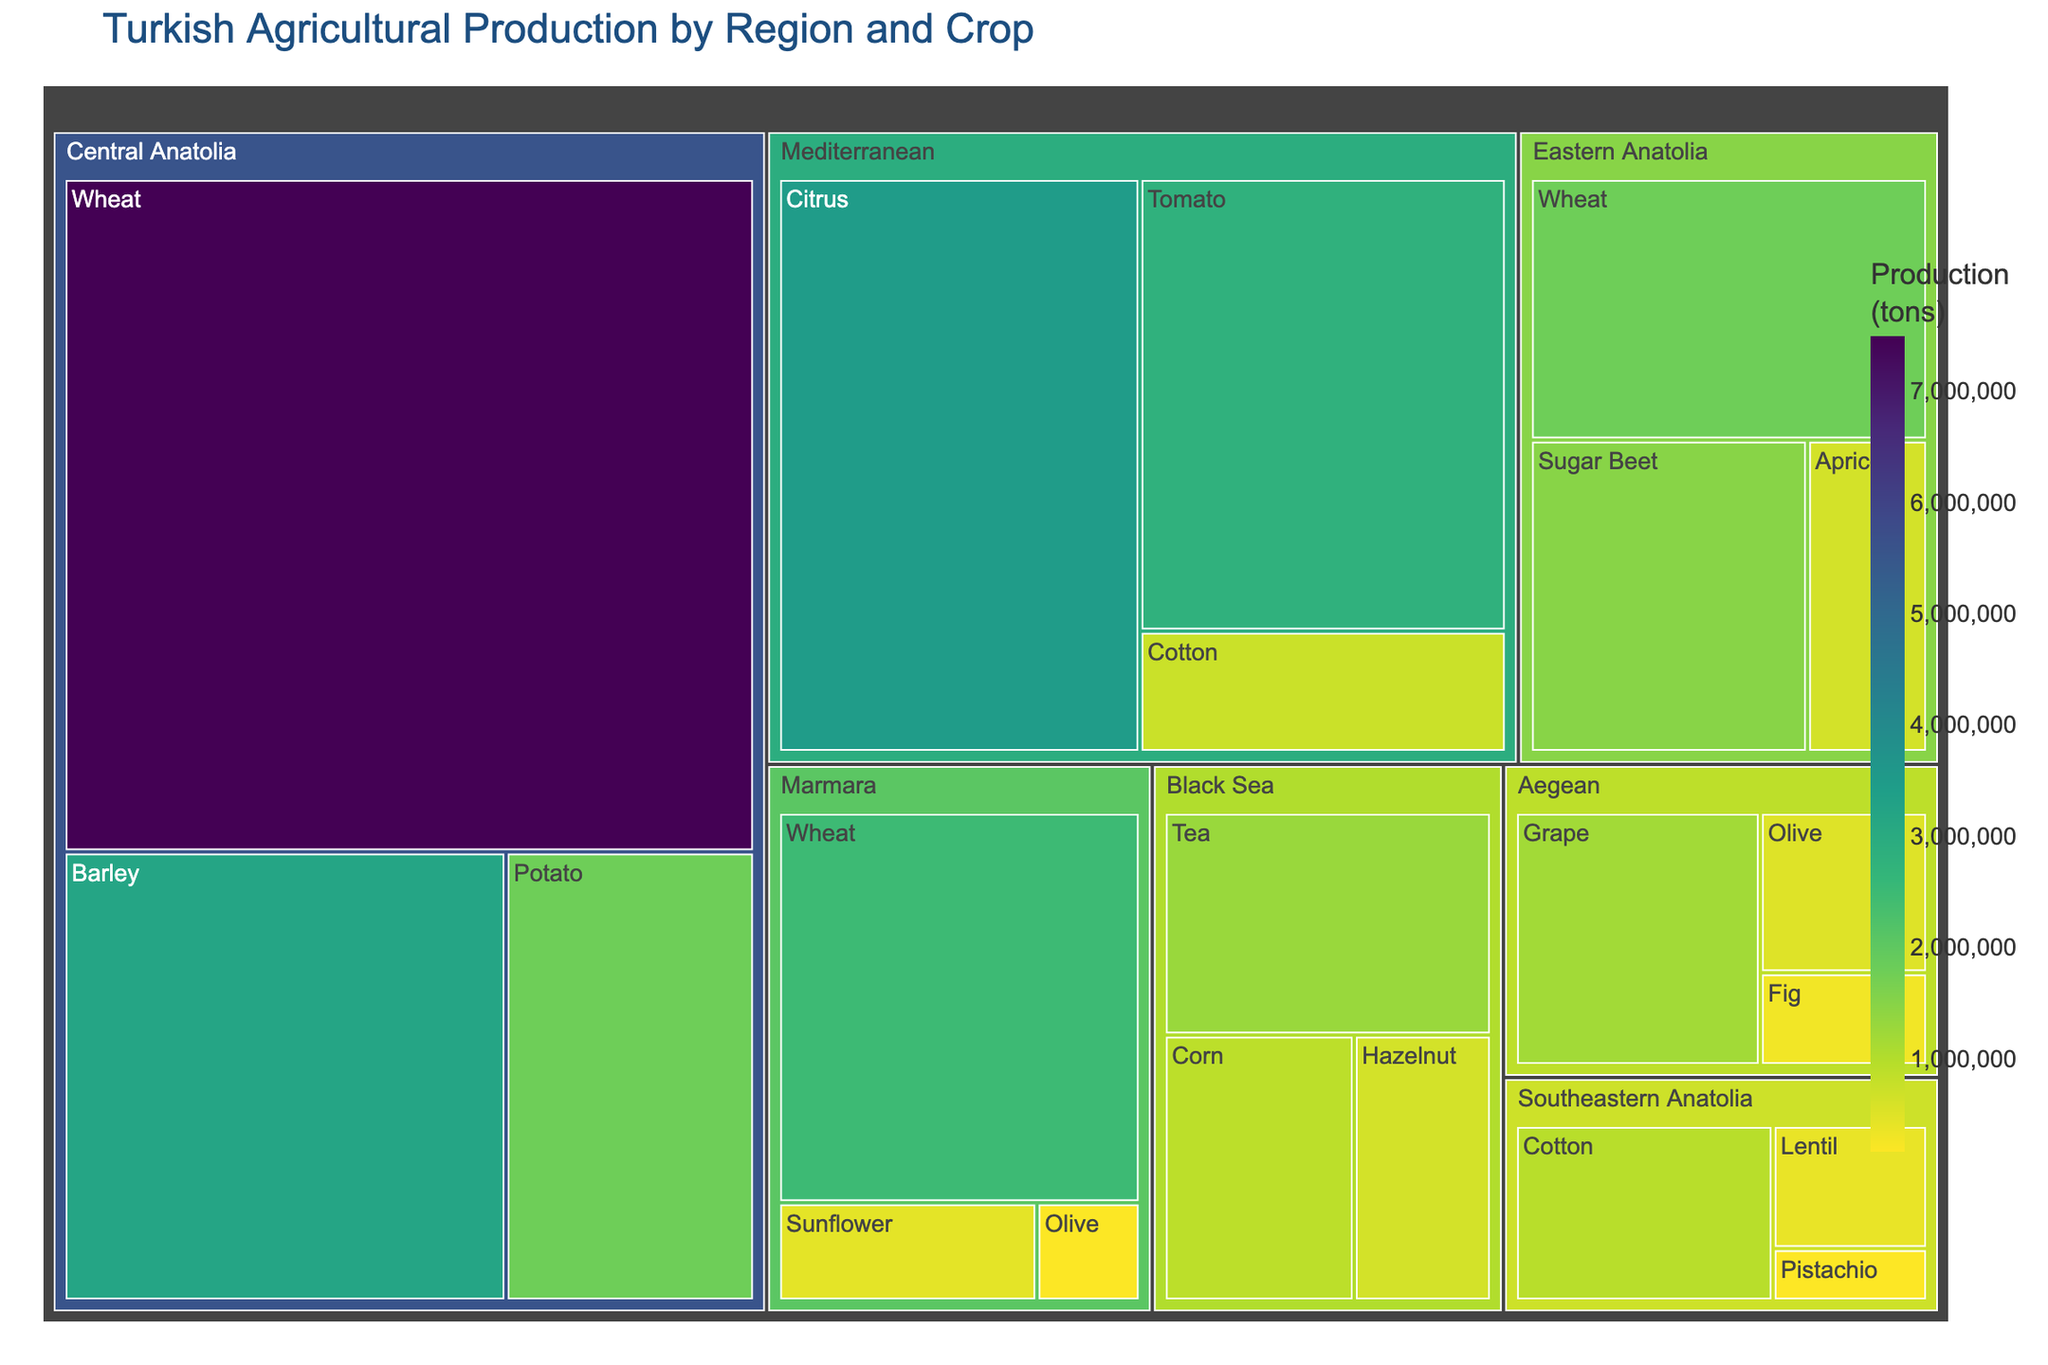Which region has the highest production of Wheat? Look for the region with the largest "Wheat" section in the treemap. Central Anatolia has the highest production of Wheat.
Answer: Central Anatolia What's the total production of Olives across all regions? Identify all the regions that produce Olives and sum their production values: Marmara (180,000) + Aegean (520,000) = 700,000 tons.
Answer: 700,000 tons Which crop in the Mediterranean region has the highest production? Within the "Mediterranean" part of the treemap, look for the largest section. Citrus has the highest production in the Mediterranean region.
Answer: Citrus How does the production of Hazelnut in the Black Sea region compare to the production of Apricot in the Eastern Anatolia region? Compare the sizes and production values of "Hazelnut" in "Black Sea" and "Apricot" in "Eastern Anatolia." Hazelnut has a production of 650,000 tons, which is equal to the Apricot production of 650,000 tons in Eastern Anatolia.
Answer: Equal What's the combined production of Tea and Corn in the Black Sea region? Find the production values of "Tea" (1,300,000) and "Corn" (900,000) in the "Black Sea" region and sum them up: 1,300,000 + 900,000 = 2,200,000 tons.
Answer: 2,200,000 tons Which region contributes the most to Cotton production in the dataset? Compare the Cotton production values across different regions depicted in the treemap. Southeastern Anatolia's Cotton production (950,000 tons) is the highest.
Answer: Southeastern Anatolia What’s the ratio of Citrus production to Tomato production in the Mediterranean region? Divide the production of Citrus (3,500,000 tons) by the production of Tomato (2,800,000 tons) in the Mediterranean: 3,500,000 / 2,800,000 ≈ 1.25.
Answer: 1.25 How many different crops are produced in the Aegean region? Count the number of unique crop sections within the "Aegean" region part of the treemap. There are three crops: Olive, Fig, and Grape.
Answer: 3 crops What is the average production of all crop types in Central Anatolia? Calculate the production values for all crops in Central Anatolia (Wheat: 7,500,000, Barley: 3,200,000, Potato: 1,800,000). Sum these up and divide by 3: (7,500,000 + 3,200,000 + 1,800,000) / 3 ≈ 4,833,333.33 tons.
Answer: ~4,833,333 tons 